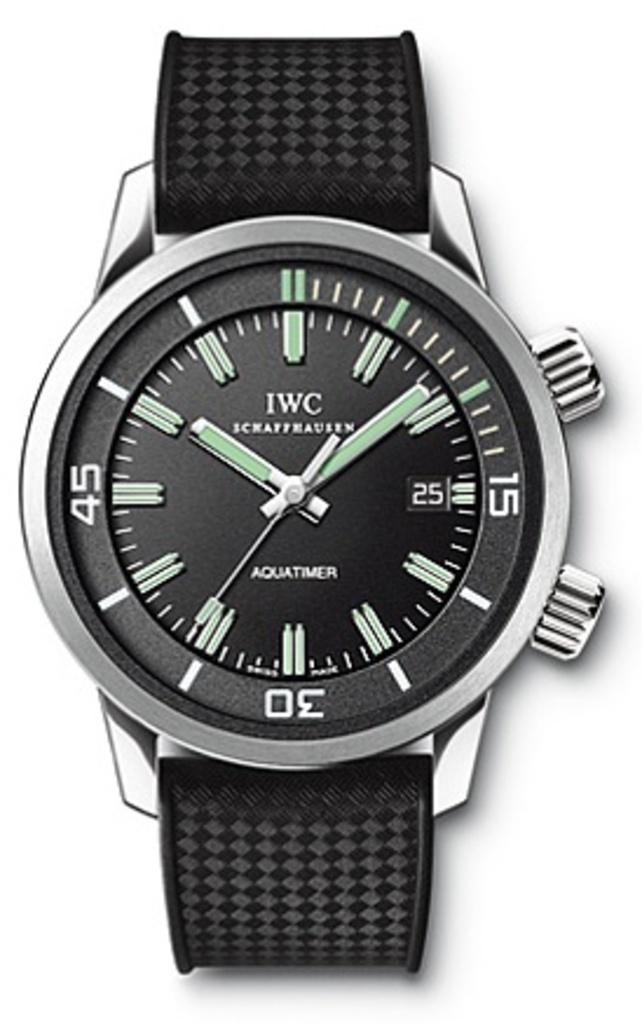<image>
Share a concise interpretation of the image provided. A black and silver watch says that it is almost 10 past 10. 